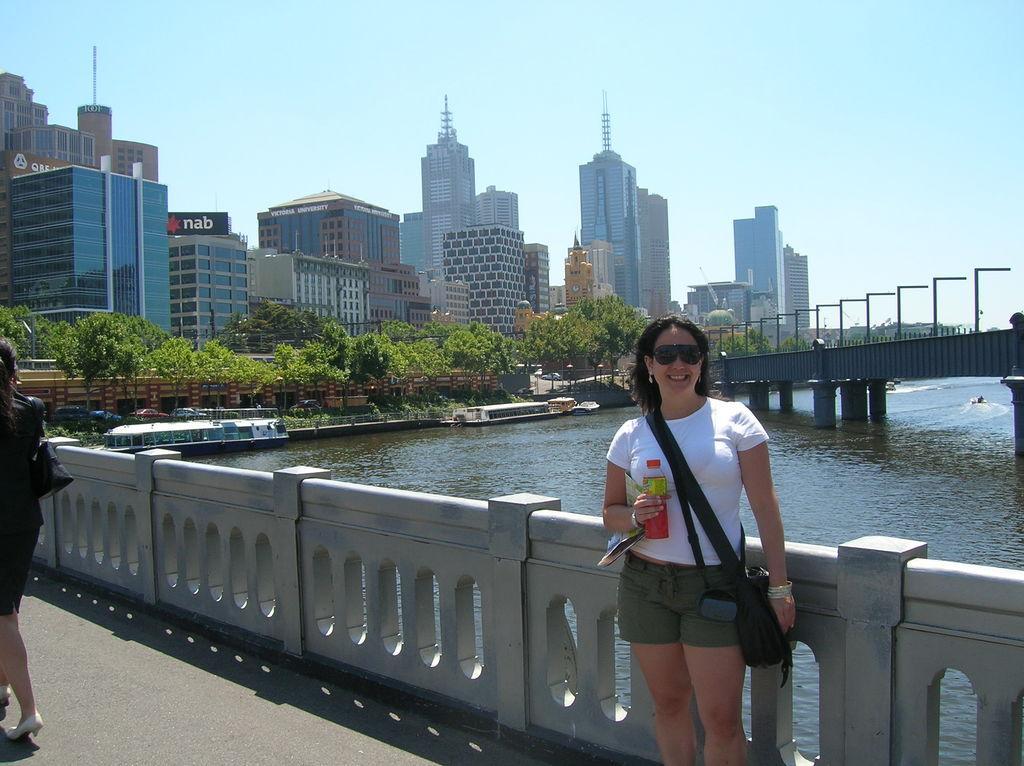Could you give a brief overview of what you see in this image? In this image we can see person holding bottle and standing on the bridge. In the background there is a river, boat, trees, buildings, lights and sky. 